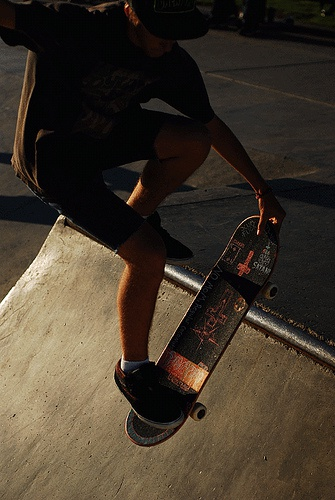Describe the objects in this image and their specific colors. I can see people in black, maroon, and gray tones and skateboard in black, maroon, and gray tones in this image. 